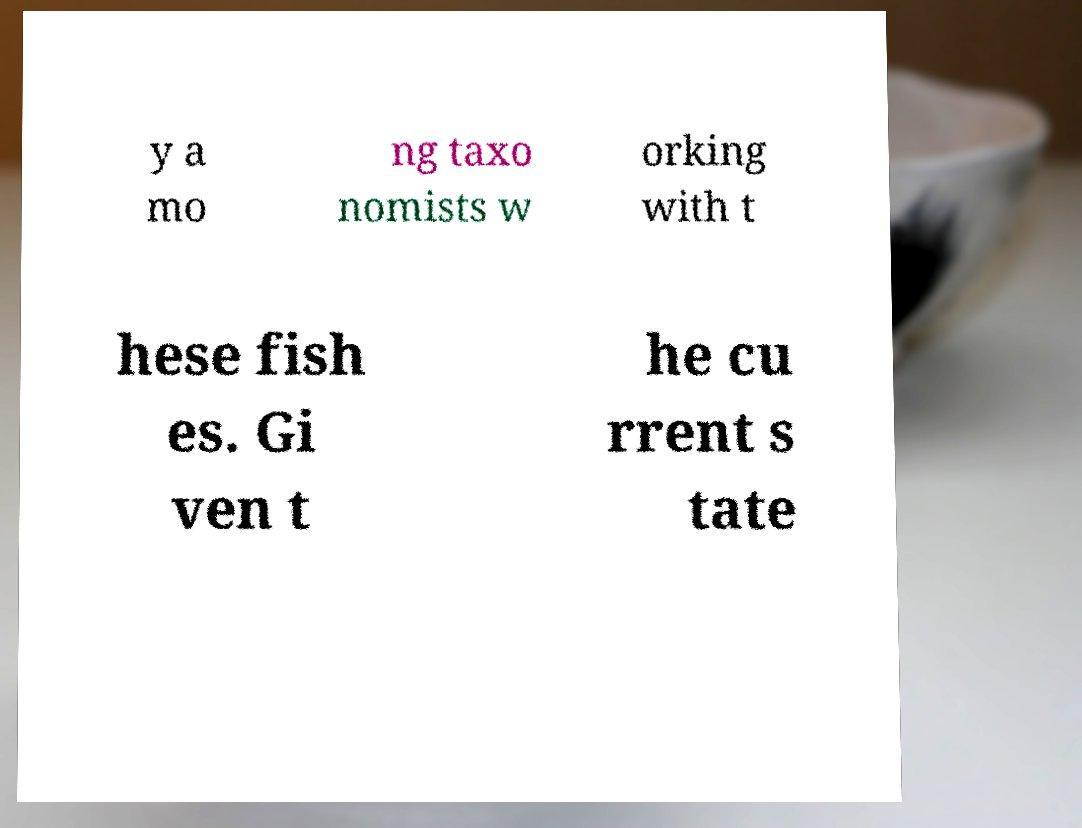I need the written content from this picture converted into text. Can you do that? y a mo ng taxo nomists w orking with t hese fish es. Gi ven t he cu rrent s tate 